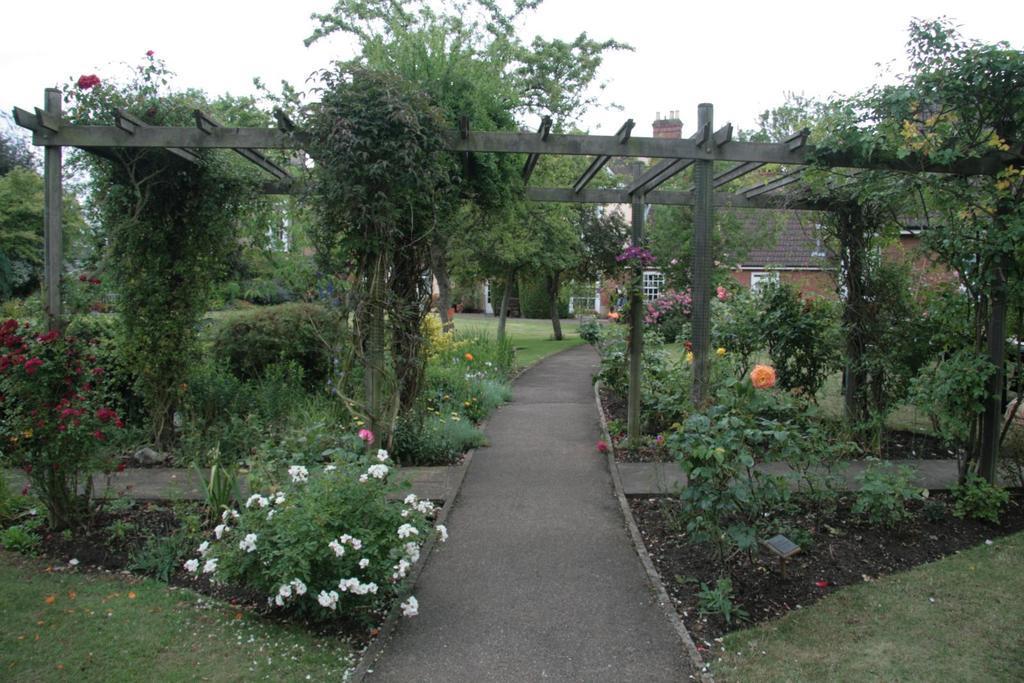Could you give a brief overview of what you see in this image? In this picture I can observe plants and grass on the ground. On the left side I can observe red and white color flowers. In the background I can observe a house and sky. 